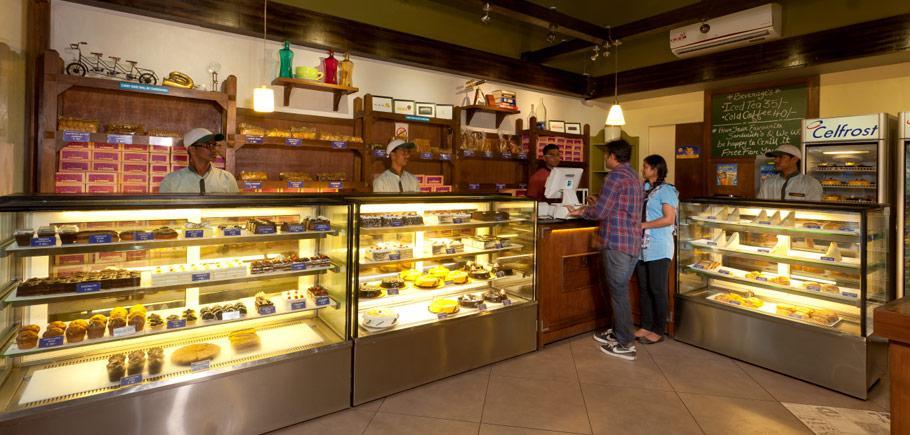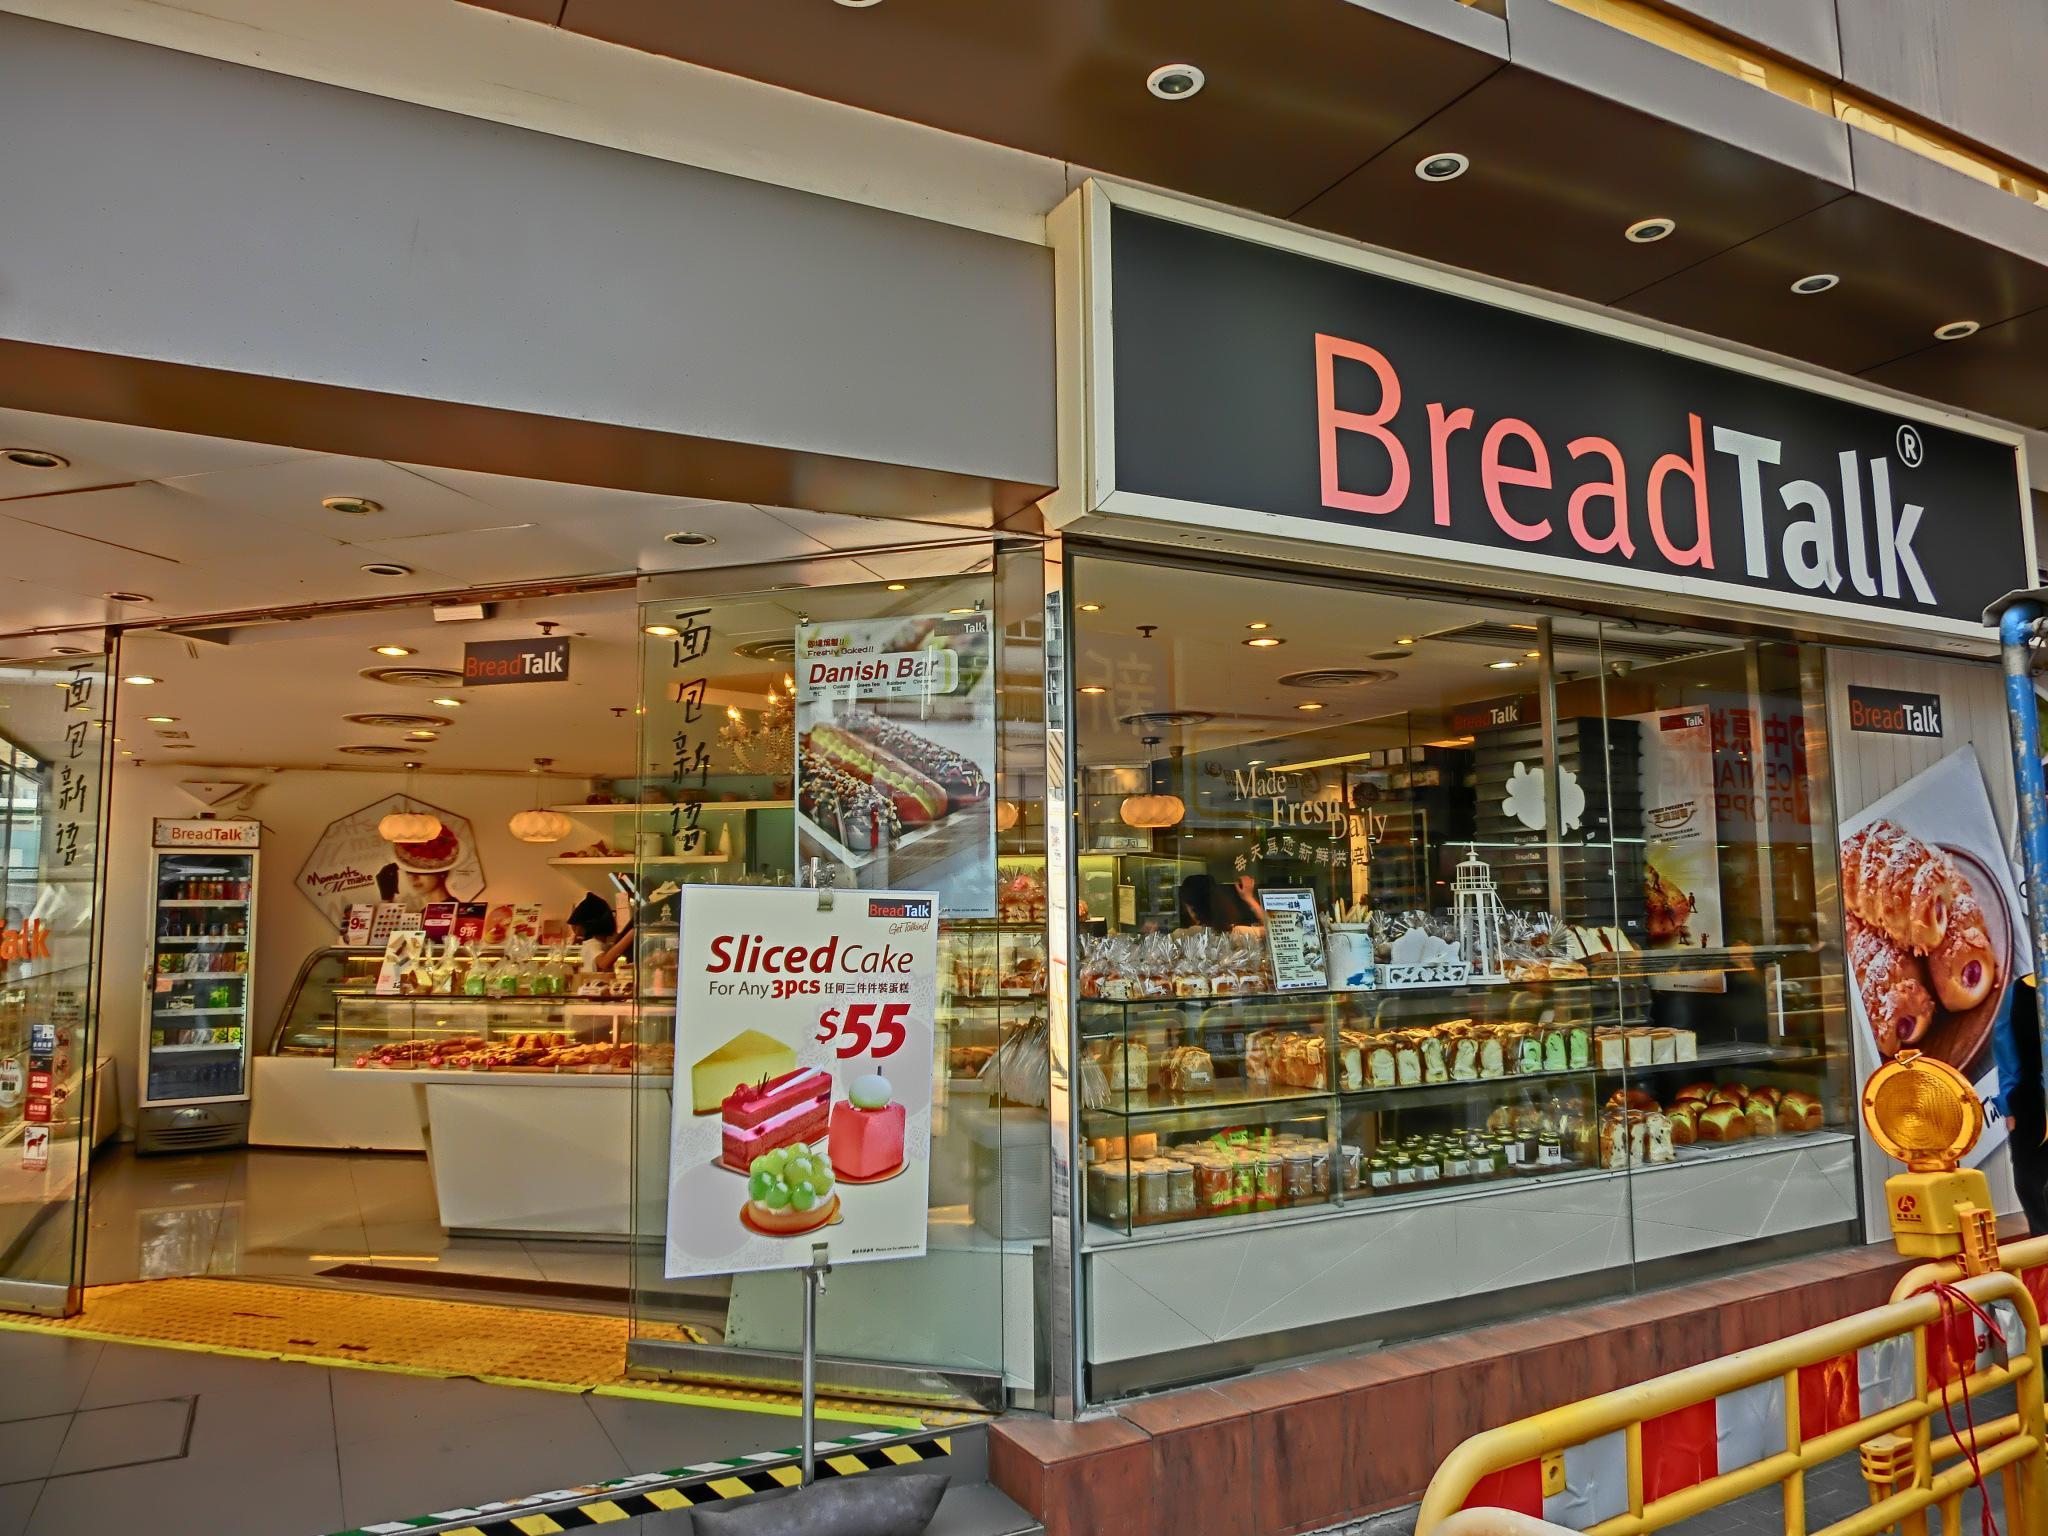The first image is the image on the left, the second image is the image on the right. Evaluate the accuracy of this statement regarding the images: "In at least one image there is no less than 4 men standing behind the baked goods counter.". Is it true? Answer yes or no. Yes. The first image is the image on the left, the second image is the image on the right. Analyze the images presented: Is the assertion "The bakery's name is visible in at least one image." valid? Answer yes or no. Yes. 